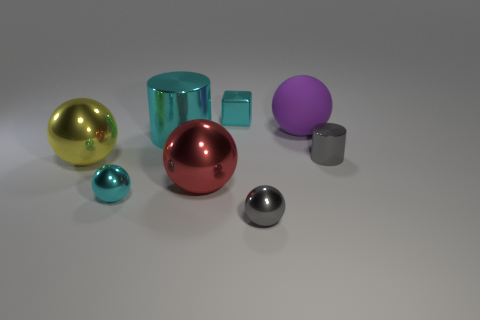Are there any other things that are made of the same material as the big purple object?
Provide a short and direct response. No. What number of large cyan objects are behind the small cyan ball?
Ensure brevity in your answer.  1. There is a big object in front of the large shiny ball to the left of the cyan metal cylinder; what is its color?
Your response must be concise. Red. Are there an equal number of cyan shiny cubes that are to the left of the cube and yellow metal objects in front of the tiny cyan ball?
Offer a terse response. Yes. How many blocks are either large yellow shiny objects or tiny things?
Give a very brief answer. 1. How many other things are made of the same material as the large yellow sphere?
Offer a terse response. 6. What is the shape of the gray shiny thing behind the large yellow metallic object?
Ensure brevity in your answer.  Cylinder. What is the material of the large ball that is to the right of the big metal sphere that is to the right of the large shiny cylinder?
Ensure brevity in your answer.  Rubber. Are there more big purple rubber balls that are in front of the small cyan shiny cube than small blue matte objects?
Your answer should be very brief. Yes. How many other things are the same color as the tiny metallic block?
Give a very brief answer. 2. 